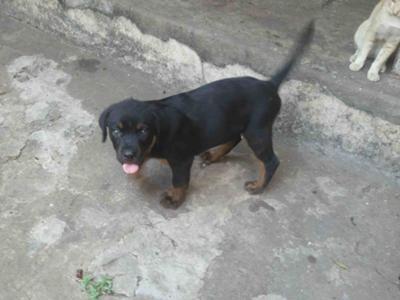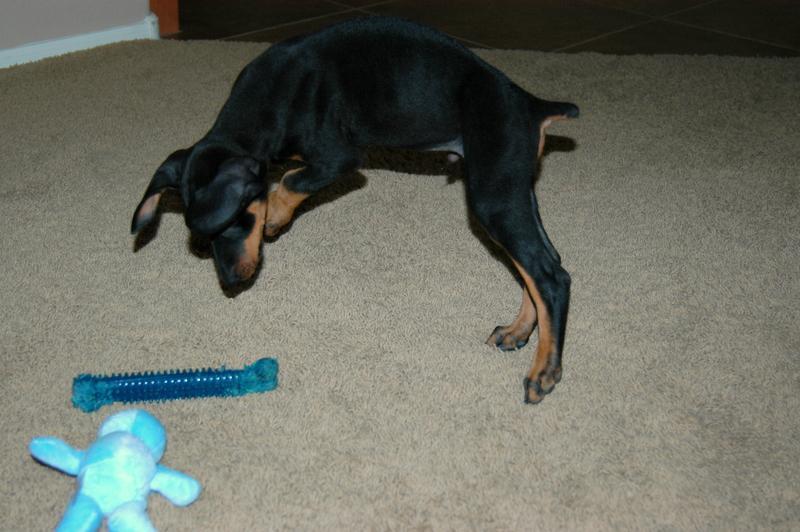The first image is the image on the left, the second image is the image on the right. Assess this claim about the two images: "In the right image, there's a Doberman sitting down.". Correct or not? Answer yes or no. No. The first image is the image on the left, the second image is the image on the right. For the images shown, is this caption "The dogs in both images are lying down." true? Answer yes or no. No. 